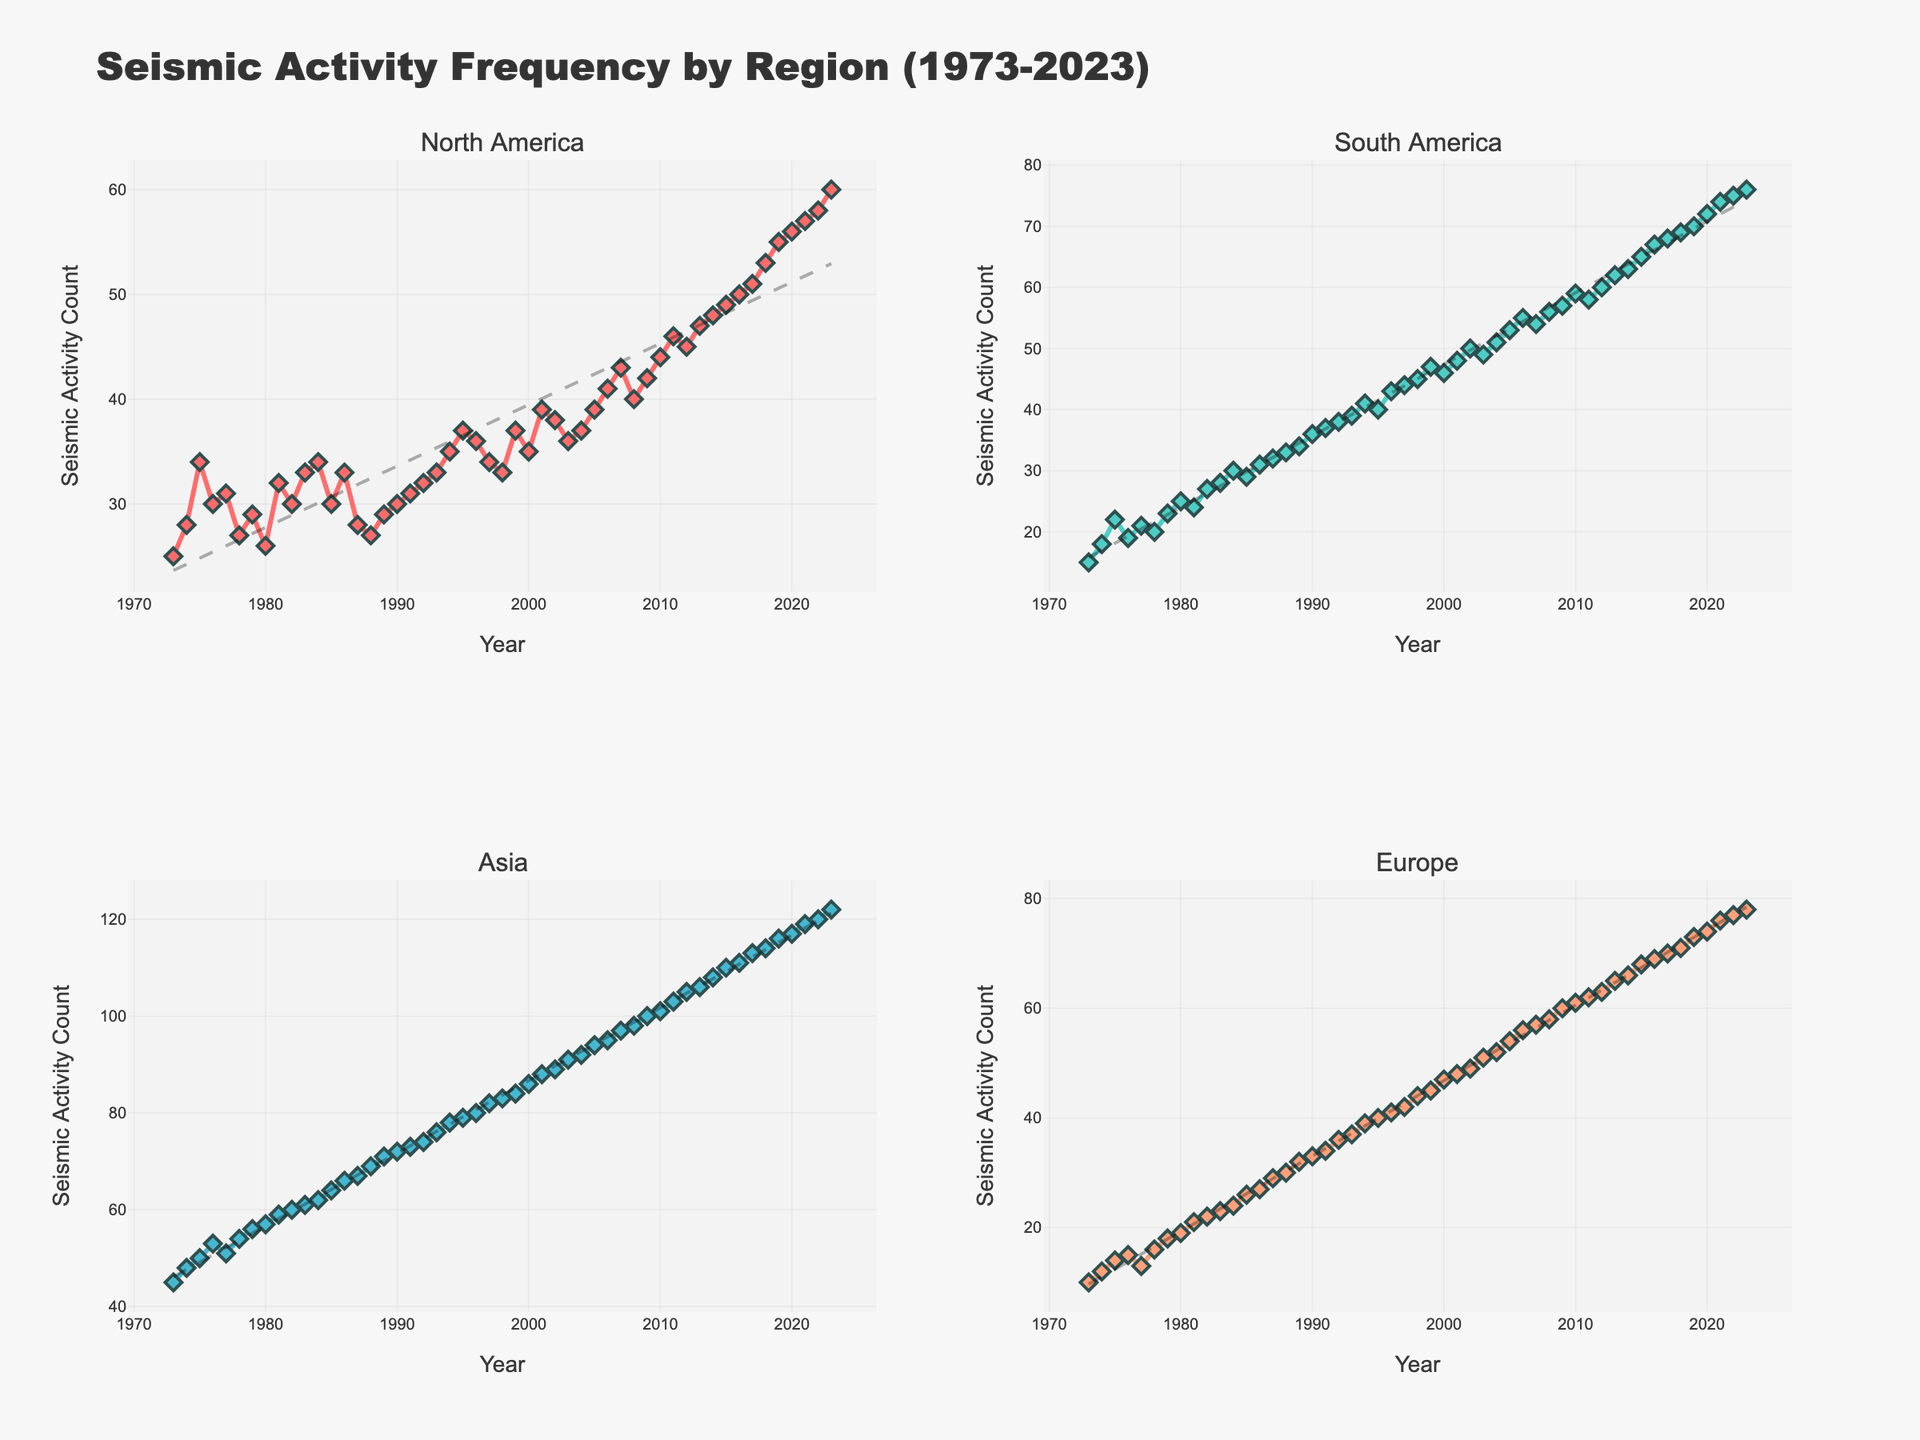what is the title of the figure? The title is usually found at the top of the figure. In this case, it reads "Seismic Activity Frequency by Region (1973-2023)."
Answer: Seismic Activity Frequency by Region (1973-2023) What do the x-axes represent in the plot? The x-axes in a time series plot typically represent the time variable. Here, the x-axes show the years from 1973 to 2023.
Answer: Year What are the y-axes labeled as? The y-axes in the plots indicate the number of events. In this case, they are labeled "Seismic Activity Count," showing the count of seismic activities each year.
Answer: Seismic Activity Count Which region appears to have the highest increase in seismic activity over the given period? By examining the trend lines in each subplot, Asia shows the steepest increasing trend, meaning it has the highest increase in seismic activity.
Answer: Asia How many subplots are present in the figure? The figure consists of multiple panels or subplots. In this case, there are four subplots, one for each region (North America, South America, Asia, Europe).
Answer: Four In which year did North America reach its highest seismic activity count? The highest point on the North America subplot corresponds to the year 2023, where the seismic activity count reaches its peak.
Answer: 2023 What is the seismic activity count in Europe in 1990? By looking at the data points on the Europe subplot, the seismic activity count for Europe in 1990 is 33.
Answer: 33 Compared to 1980, how much did the seismic activity count increase in South America by the year 2000? In 1980, the seismic activity count in South America was 25. By 2000, it increased to 46. The difference is (46 - 25) = 21.
Answer: 21 Which region had the least seismic activity in 1973? By referencing the starting data points in the subplots for the year 1973, Europe had the least number of seismic activities with a count of 10.
Answer: Europe What is the overall trend of seismic activity in Asia from 1973 to 2023? By observing the trend line in Asia's subplot, one can see a steadily increasing pattern over the years, indicating a consistent rise in seismic activity.
Answer: Increasing 